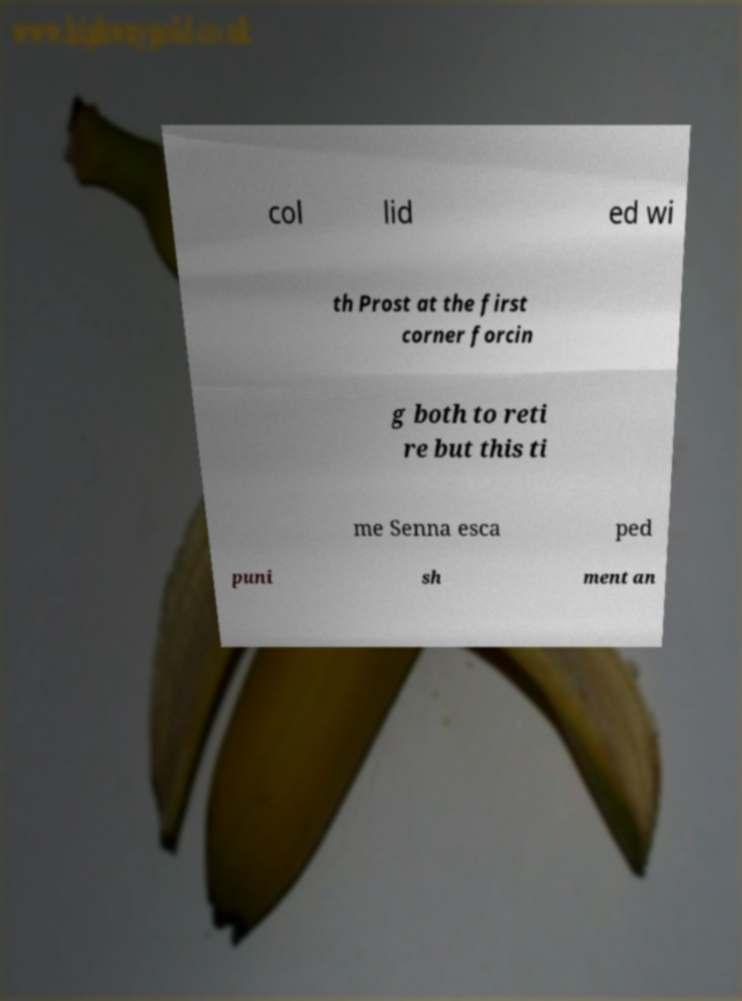Please read and relay the text visible in this image. What does it say? col lid ed wi th Prost at the first corner forcin g both to reti re but this ti me Senna esca ped puni sh ment an 